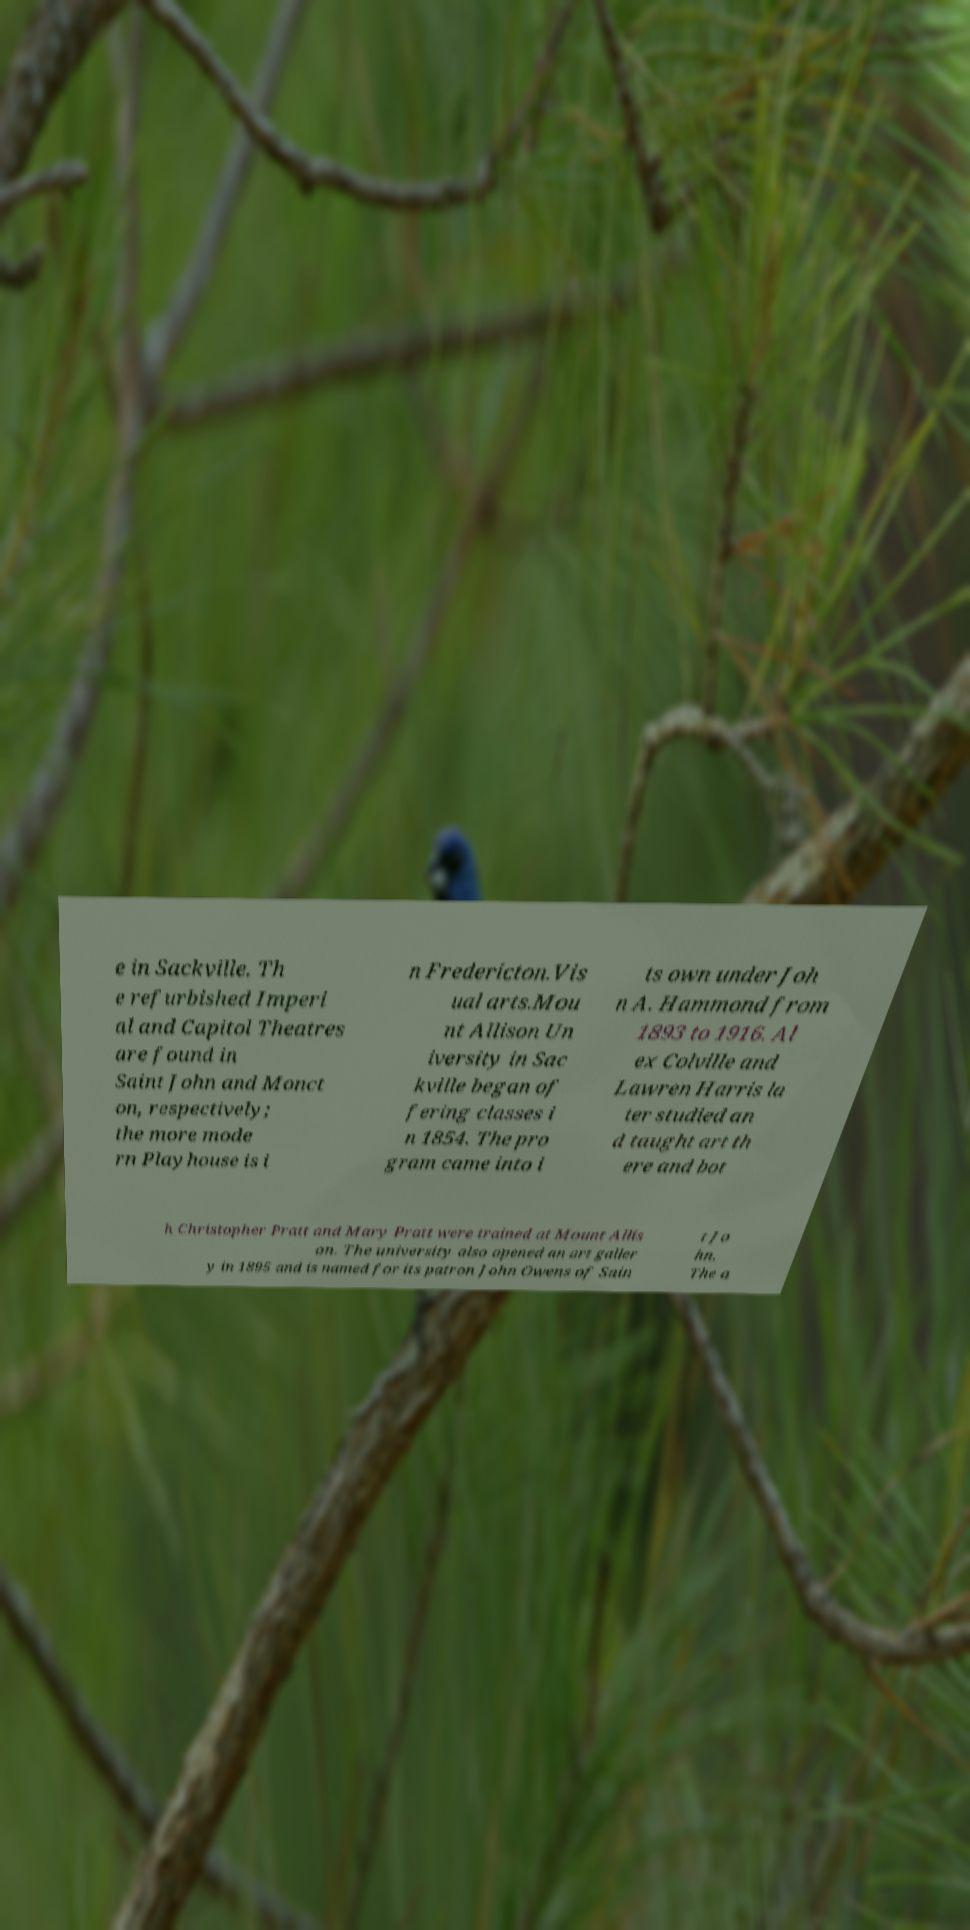For documentation purposes, I need the text within this image transcribed. Could you provide that? e in Sackville. Th e refurbished Imperi al and Capitol Theatres are found in Saint John and Monct on, respectively; the more mode rn Playhouse is i n Fredericton.Vis ual arts.Mou nt Allison Un iversity in Sac kville began of fering classes i n 1854. The pro gram came into i ts own under Joh n A. Hammond from 1893 to 1916. Al ex Colville and Lawren Harris la ter studied an d taught art th ere and bot h Christopher Pratt and Mary Pratt were trained at Mount Allis on. The university also opened an art galler y in 1895 and is named for its patron John Owens of Sain t Jo hn. The a 